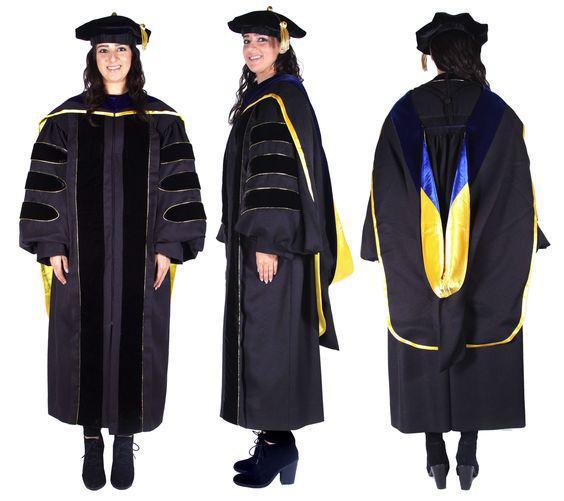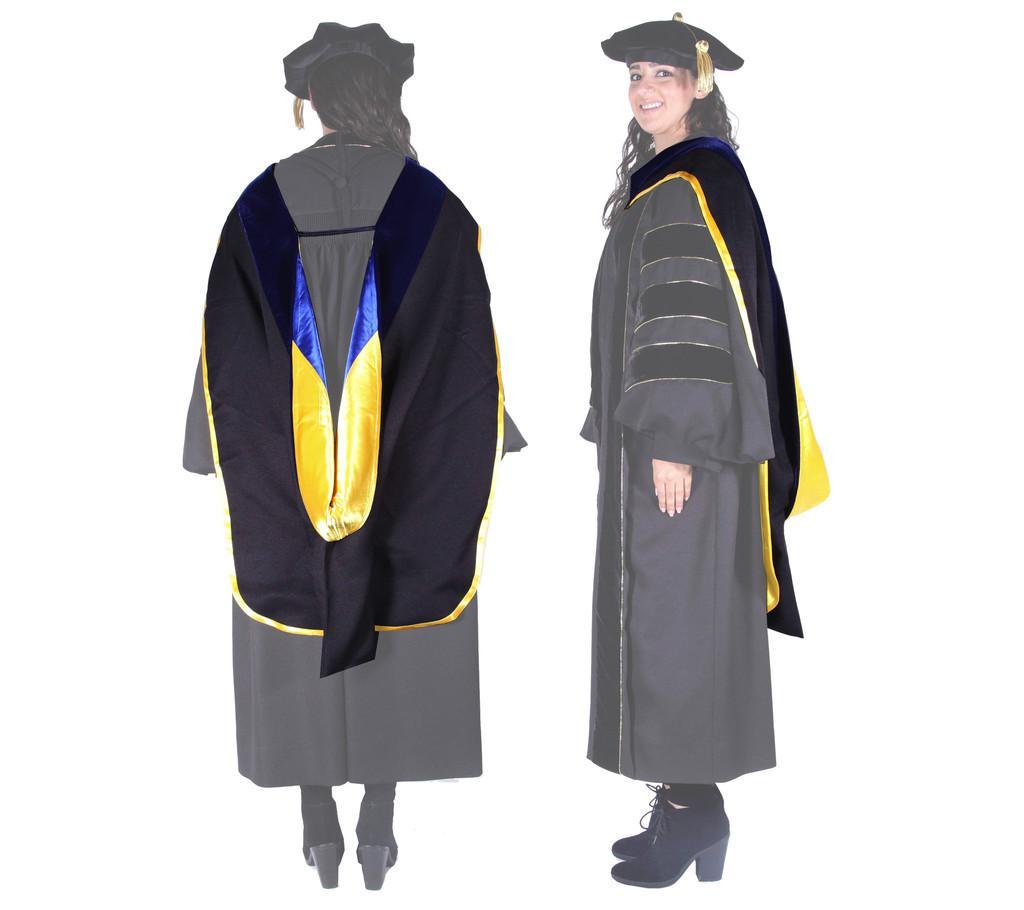The first image is the image on the left, the second image is the image on the right. For the images shown, is this caption "Three people are modeling graduation attire in one of the images." true? Answer yes or no. Yes. The first image is the image on the left, the second image is the image on the right. Assess this claim about the two images: "One image shows the same male graduate in multiple poses, and the other image includes a female graduate.". Correct or not? Answer yes or no. No. 